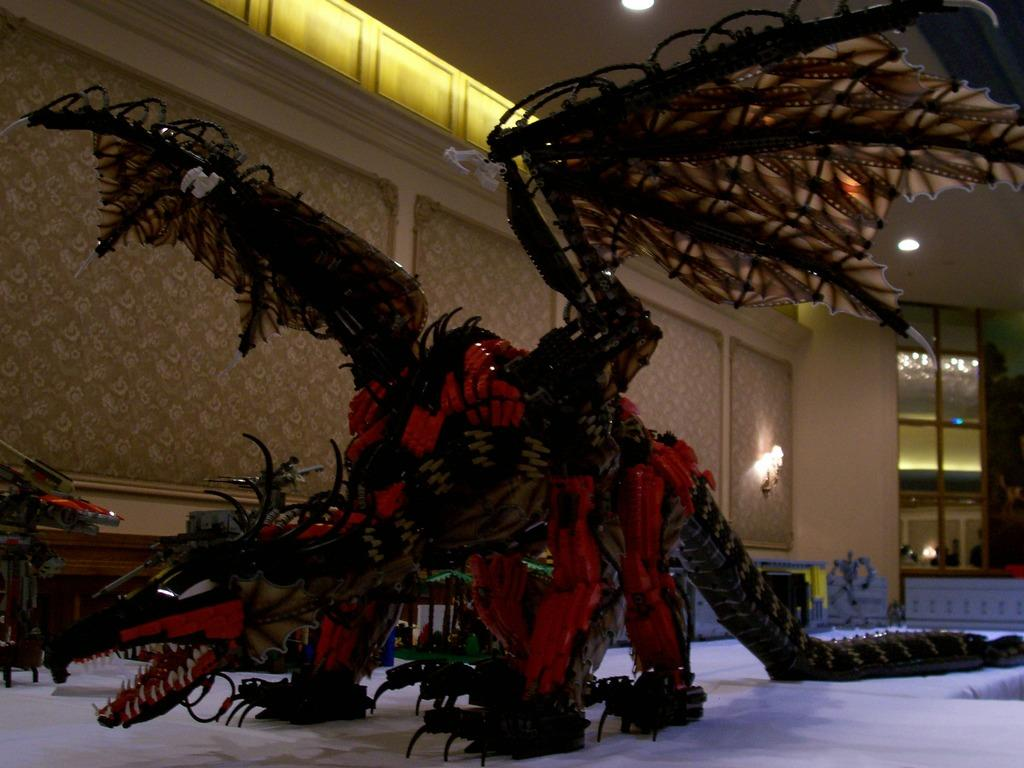What is the main subject of the image? There is a depiction of a dinosaur in the image. What can be seen in the background of the image? There is a wall in the background of the image. What is hanging on the wall in the background? There are lamps hanging on the wall in the background. What is visible at the top of the image? There is a ceiling visible at the top of the image. What is the price of the dinosaur depicted in the image? The image is a depiction of a dinosaur, not a real dinosaur, so there is no price associated with it. 